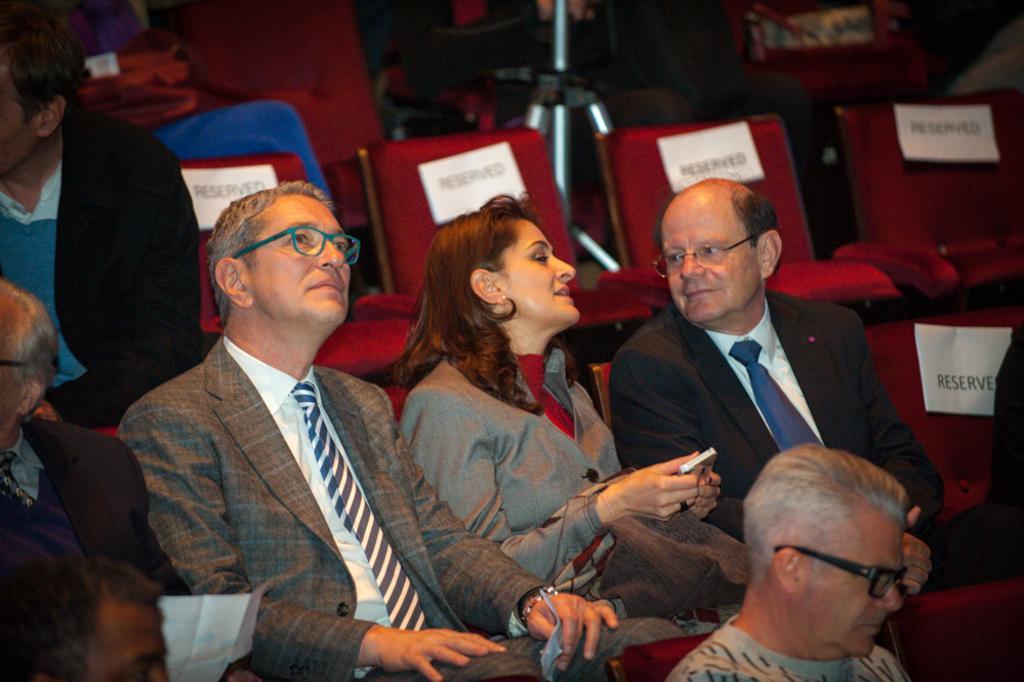Can you describe this image briefly? This image is taken indoors. In this image a few people are sitting on the chairs. In the middle of the image a woman is sitting on the chair and she is holding a mobile phone in her hands and there are many empty chairs with a few posts and text on them. 